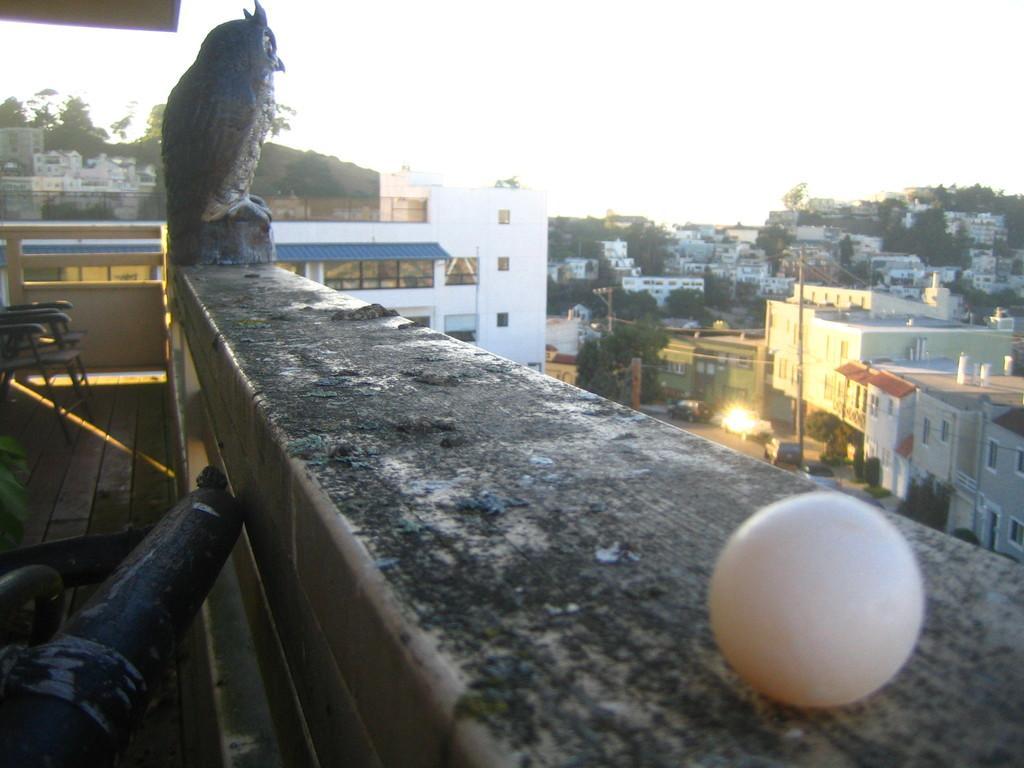Describe this image in one or two sentences. This picture is clicked outside the city. In front of the picture, we see a white ball. Beside that, we see a statue of the bird is placed on the wall. Beside that, there are chairs. On the right side, we see buildings and poles. We see cars moving on the road. There are trees and buildings in the background. At the top of the picture, we see the sky. In the left bottom of the picture, we see a black color thing. 